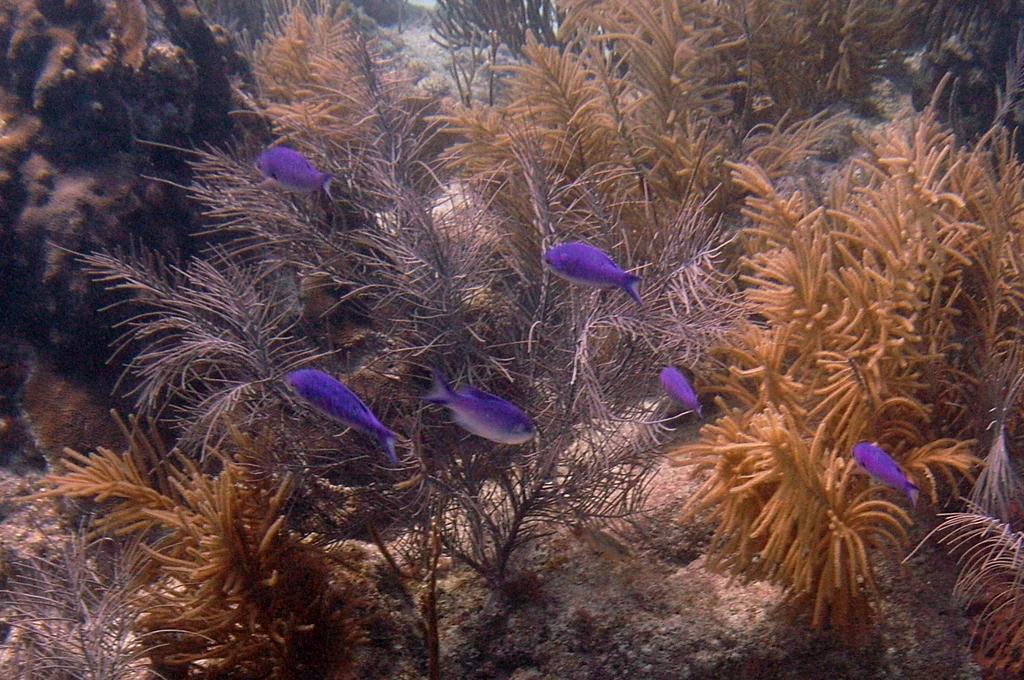Could you give a brief overview of what you see in this image? In this image, we can see some water plants. There are fishes in the middle of the image. 